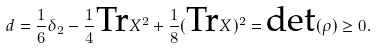<formula> <loc_0><loc_0><loc_500><loc_500>d = \frac { 1 } { 6 } \delta _ { 2 } - \frac { 1 } { 4 } \text {Tr} X ^ { 2 } + \frac { 1 } { 8 } ( \text {Tr} X ) ^ { 2 } = \text {det} ( \rho ) \geq 0 .</formula> 